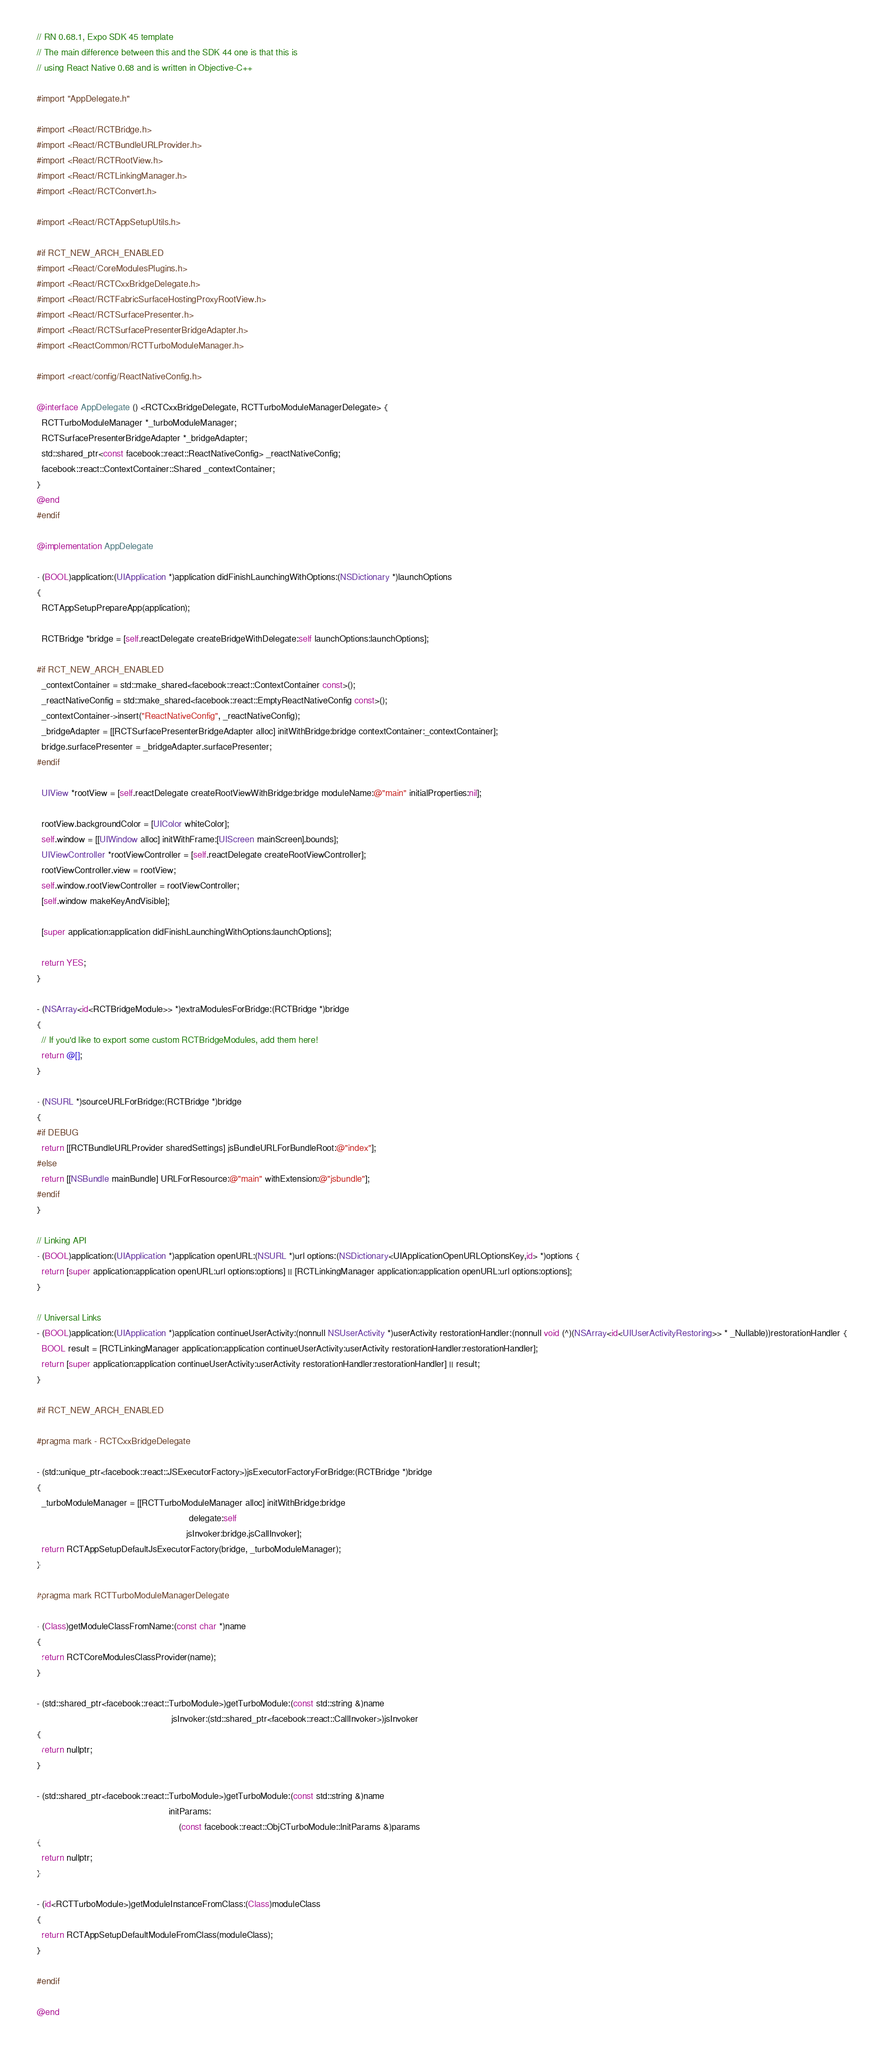Convert code to text. <code><loc_0><loc_0><loc_500><loc_500><_ObjectiveC_>// RN 0.68.1, Expo SDK 45 template
// The main difference between this and the SDK 44 one is that this is
// using React Native 0.68 and is written in Objective-C++

#import "AppDelegate.h"

#import <React/RCTBridge.h>
#import <React/RCTBundleURLProvider.h>
#import <React/RCTRootView.h>
#import <React/RCTLinkingManager.h>
#import <React/RCTConvert.h>

#import <React/RCTAppSetupUtils.h>

#if RCT_NEW_ARCH_ENABLED
#import <React/CoreModulesPlugins.h>
#import <React/RCTCxxBridgeDelegate.h>
#import <React/RCTFabricSurfaceHostingProxyRootView.h>
#import <React/RCTSurfacePresenter.h>
#import <React/RCTSurfacePresenterBridgeAdapter.h>
#import <ReactCommon/RCTTurboModuleManager.h>

#import <react/config/ReactNativeConfig.h>

@interface AppDelegate () <RCTCxxBridgeDelegate, RCTTurboModuleManagerDelegate> {
  RCTTurboModuleManager *_turboModuleManager;
  RCTSurfacePresenterBridgeAdapter *_bridgeAdapter;
  std::shared_ptr<const facebook::react::ReactNativeConfig> _reactNativeConfig;
  facebook::react::ContextContainer::Shared _contextContainer;
}
@end
#endif

@implementation AppDelegate

- (BOOL)application:(UIApplication *)application didFinishLaunchingWithOptions:(NSDictionary *)launchOptions
{
  RCTAppSetupPrepareApp(application);

  RCTBridge *bridge = [self.reactDelegate createBridgeWithDelegate:self launchOptions:launchOptions];

#if RCT_NEW_ARCH_ENABLED
  _contextContainer = std::make_shared<facebook::react::ContextContainer const>();
  _reactNativeConfig = std::make_shared<facebook::react::EmptyReactNativeConfig const>();
  _contextContainer->insert("ReactNativeConfig", _reactNativeConfig);
  _bridgeAdapter = [[RCTSurfacePresenterBridgeAdapter alloc] initWithBridge:bridge contextContainer:_contextContainer];
  bridge.surfacePresenter = _bridgeAdapter.surfacePresenter;
#endif

  UIView *rootView = [self.reactDelegate createRootViewWithBridge:bridge moduleName:@"main" initialProperties:nil];

  rootView.backgroundColor = [UIColor whiteColor];
  self.window = [[UIWindow alloc] initWithFrame:[UIScreen mainScreen].bounds];
  UIViewController *rootViewController = [self.reactDelegate createRootViewController];
  rootViewController.view = rootView;
  self.window.rootViewController = rootViewController;
  [self.window makeKeyAndVisible];

  [super application:application didFinishLaunchingWithOptions:launchOptions];

  return YES;
}

- (NSArray<id<RCTBridgeModule>> *)extraModulesForBridge:(RCTBridge *)bridge
{
  // If you'd like to export some custom RCTBridgeModules, add them here!
  return @[];
}

- (NSURL *)sourceURLForBridge:(RCTBridge *)bridge
{
#if DEBUG
  return [[RCTBundleURLProvider sharedSettings] jsBundleURLForBundleRoot:@"index"];
#else
  return [[NSBundle mainBundle] URLForResource:@"main" withExtension:@"jsbundle"];
#endif
}

// Linking API
- (BOOL)application:(UIApplication *)application openURL:(NSURL *)url options:(NSDictionary<UIApplicationOpenURLOptionsKey,id> *)options {
  return [super application:application openURL:url options:options] || [RCTLinkingManager application:application openURL:url options:options];
}

// Universal Links
- (BOOL)application:(UIApplication *)application continueUserActivity:(nonnull NSUserActivity *)userActivity restorationHandler:(nonnull void (^)(NSArray<id<UIUserActivityRestoring>> * _Nullable))restorationHandler {
  BOOL result = [RCTLinkingManager application:application continueUserActivity:userActivity restorationHandler:restorationHandler];
  return [super application:application continueUserActivity:userActivity restorationHandler:restorationHandler] || result;
}

#if RCT_NEW_ARCH_ENABLED

#pragma mark - RCTCxxBridgeDelegate

- (std::unique_ptr<facebook::react::JSExecutorFactory>)jsExecutorFactoryForBridge:(RCTBridge *)bridge
{
  _turboModuleManager = [[RCTTurboModuleManager alloc] initWithBridge:bridge
                                                             delegate:self
                                                            jsInvoker:bridge.jsCallInvoker];
  return RCTAppSetupDefaultJsExecutorFactory(bridge, _turboModuleManager);
}

#pragma mark RCTTurboModuleManagerDelegate

- (Class)getModuleClassFromName:(const char *)name
{
  return RCTCoreModulesClassProvider(name);
}

- (std::shared_ptr<facebook::react::TurboModule>)getTurboModule:(const std::string &)name
                                                      jsInvoker:(std::shared_ptr<facebook::react::CallInvoker>)jsInvoker
{
  return nullptr;
}

- (std::shared_ptr<facebook::react::TurboModule>)getTurboModule:(const std::string &)name
                                                     initParams:
                                                         (const facebook::react::ObjCTurboModule::InitParams &)params
{
  return nullptr;
}

- (id<RCTTurboModule>)getModuleInstanceFromClass:(Class)moduleClass
{
  return RCTAppSetupDefaultModuleFromClass(moduleClass);
}

#endif

@end
</code> 